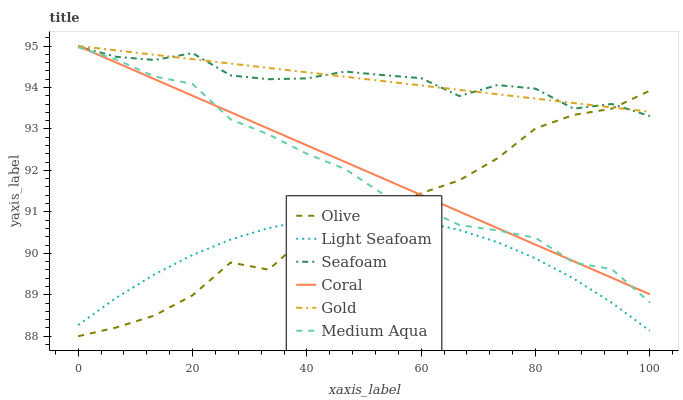Does Light Seafoam have the minimum area under the curve?
Answer yes or no. Yes. Does Gold have the maximum area under the curve?
Answer yes or no. Yes. Does Coral have the minimum area under the curve?
Answer yes or no. No. Does Coral have the maximum area under the curve?
Answer yes or no. No. Is Gold the smoothest?
Answer yes or no. Yes. Is Olive the roughest?
Answer yes or no. Yes. Is Coral the smoothest?
Answer yes or no. No. Is Coral the roughest?
Answer yes or no. No. Does Olive have the lowest value?
Answer yes or no. Yes. Does Coral have the lowest value?
Answer yes or no. No. Does Coral have the highest value?
Answer yes or no. Yes. Does Seafoam have the highest value?
Answer yes or no. No. Is Light Seafoam less than Gold?
Answer yes or no. Yes. Is Coral greater than Light Seafoam?
Answer yes or no. Yes. Does Olive intersect Medium Aqua?
Answer yes or no. Yes. Is Olive less than Medium Aqua?
Answer yes or no. No. Is Olive greater than Medium Aqua?
Answer yes or no. No. Does Light Seafoam intersect Gold?
Answer yes or no. No. 